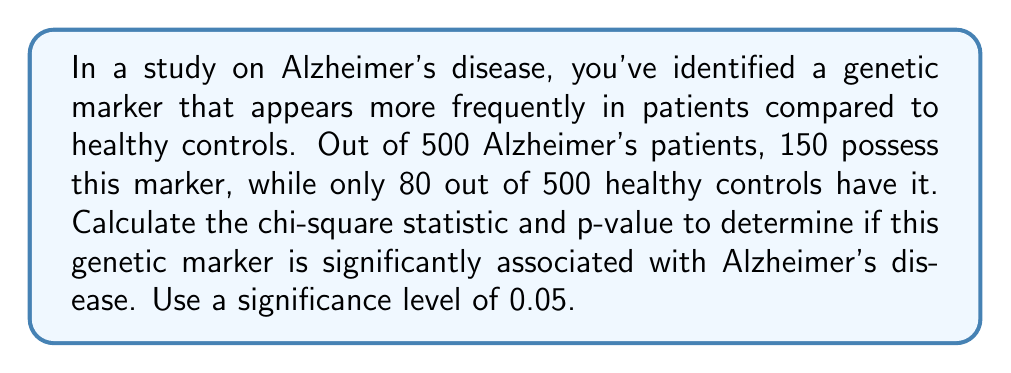Teach me how to tackle this problem. To determine if the genetic marker is significantly associated with Alzheimer's disease, we'll use the chi-square test of independence.

Step 1: Set up the contingency table

|              | Marker Present | Marker Absent | Total |
|--------------|----------------|---------------|-------|
| Alzheimer's  | 150            | 350           | 500   |
| Control      | 80             | 420           | 500   |
| Total        | 230            | 770           | 1000  |

Step 2: Calculate expected frequencies for each cell
Expected frequency = (row total × column total) / grand total

E(Alzheimer's, Present) = (500 × 230) / 1000 = 115
E(Alzheimer's, Absent) = (500 × 770) / 1000 = 385
E(Control, Present) = (500 × 230) / 1000 = 115
E(Control, Absent) = (500 × 770) / 1000 = 385

Step 3: Calculate the chi-square statistic
$$\chi^2 = \sum \frac{(O - E)^2}{E}$$

Where O is the observed frequency and E is the expected frequency.

$$\chi^2 = \frac{(150 - 115)^2}{115} + \frac{(350 - 385)^2}{385} + \frac{(80 - 115)^2}{115} + \frac{(420 - 385)^2}{385}$$
$$\chi^2 = 10.65 + 3.18 + 10.65 + 3.18 = 27.66$$

Step 4: Determine the degrees of freedom (df)
df = (rows - 1) × (columns - 1) = (2 - 1) × (2 - 1) = 1

Step 5: Find the critical value
For df = 1 and α = 0.05, the critical value is 3.841.

Step 6: Calculate the p-value
Using a chi-square distribution calculator or table, we find that for χ² = 27.66 and df = 1, p < 0.00001.

Step 7: Interpret the results
Since the calculated χ² (27.66) is greater than the critical value (3.841) and p < 0.05, we reject the null hypothesis. This means there is a statistically significant association between the genetic marker and Alzheimer's disease.
Answer: χ² = 27.66, p < 0.00001 